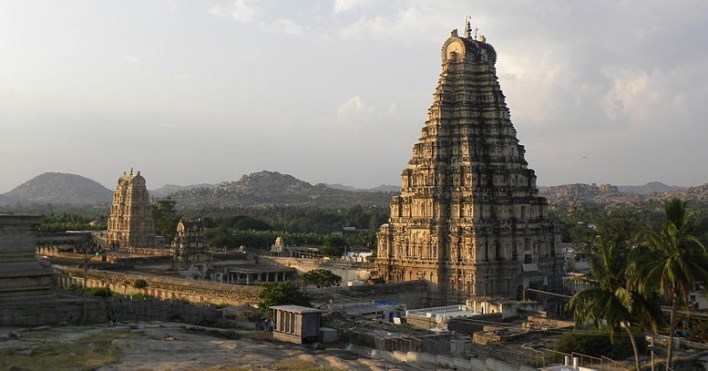What are some architectural features that stand out in the temple shown in the image? The Virupaksha Temple's gopuram is undoubtedly its most prominent architectural feature, characterized by its pyramidal tower built in the Dravidian style. The tower is adorned with a plethora of sculptures and bas-reliefs depicting Hindu deities, mythical creatures, and scenes from epic tales. Another distinct feature includes the temple's pillared halls, which are replete with intricately carved columns, each telling a story of its own. The temple complex also includes courtyards, smaller shrines, and remains of civic structures that once supported the temple's functioning. 